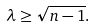Convert formula to latex. <formula><loc_0><loc_0><loc_500><loc_500>\lambda \geq \sqrt { n - 1 } .</formula> 